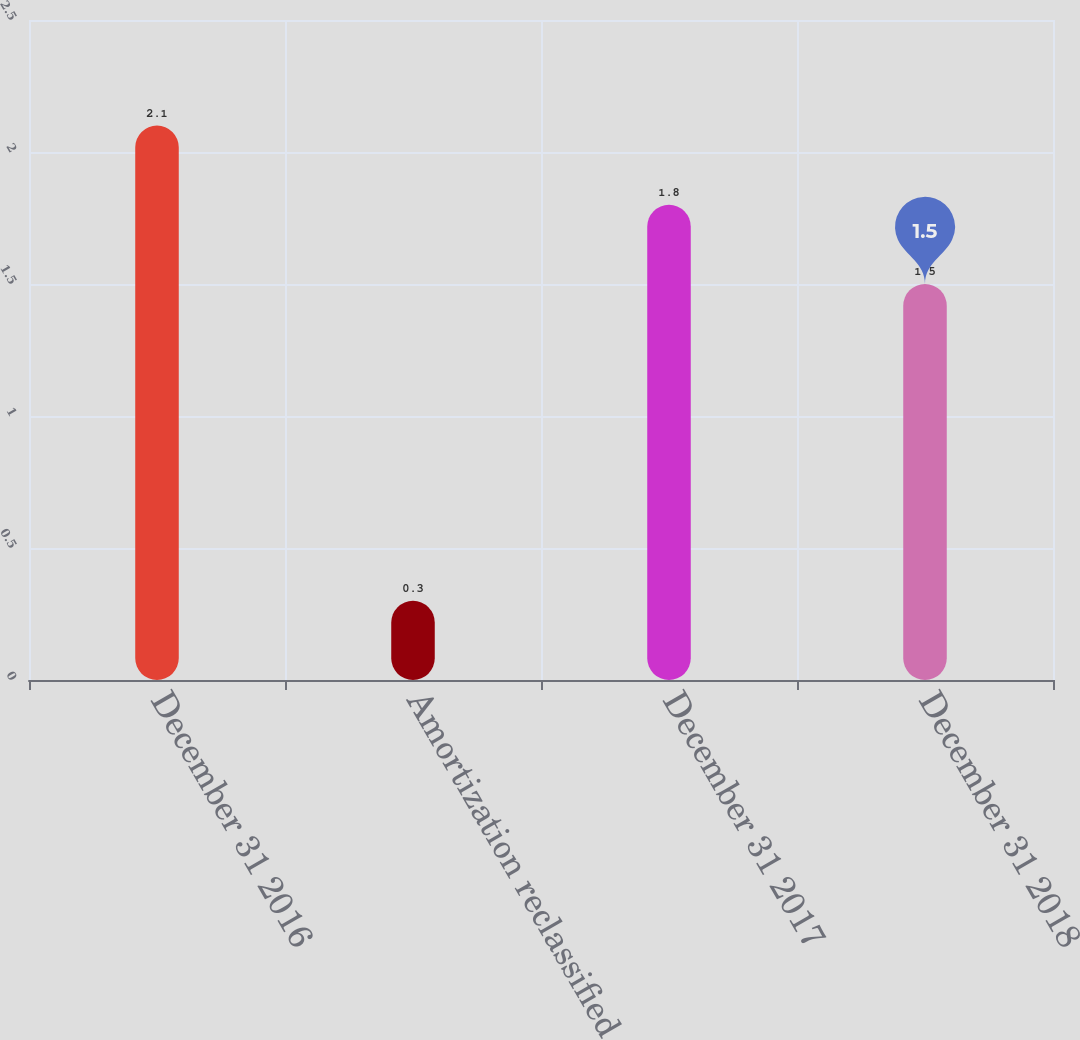Convert chart. <chart><loc_0><loc_0><loc_500><loc_500><bar_chart><fcel>December 31 2016<fcel>Amortization reclassified to<fcel>December 31 2017<fcel>December 31 2018<nl><fcel>2.1<fcel>0.3<fcel>1.8<fcel>1.5<nl></chart> 